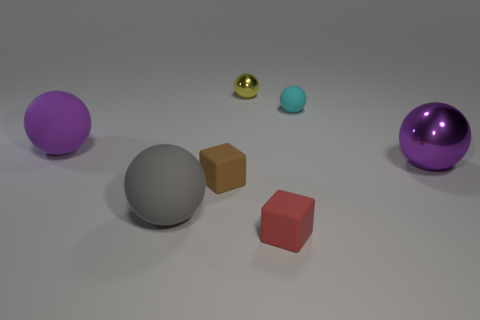Subtract all gray spheres. How many spheres are left? 4 Subtract all big gray spheres. How many spheres are left? 4 Subtract 1 spheres. How many spheres are left? 4 Subtract all blue spheres. Subtract all red cubes. How many spheres are left? 5 Add 2 small red rubber things. How many objects exist? 9 Subtract all balls. How many objects are left? 2 Add 5 large purple metallic spheres. How many large purple metallic spheres are left? 6 Add 7 purple matte balls. How many purple matte balls exist? 8 Subtract 0 brown cylinders. How many objects are left? 7 Subtract all large green spheres. Subtract all small red rubber things. How many objects are left? 6 